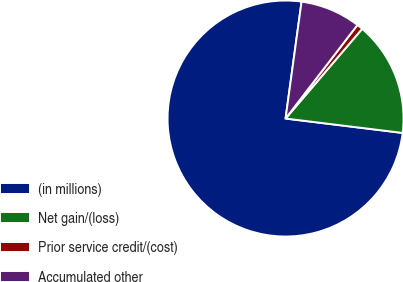<chart> <loc_0><loc_0><loc_500><loc_500><pie_chart><fcel>(in millions)<fcel>Net gain/(loss)<fcel>Prior service credit/(cost)<fcel>Accumulated other<nl><fcel>75.21%<fcel>15.7%<fcel>0.82%<fcel>8.26%<nl></chart> 